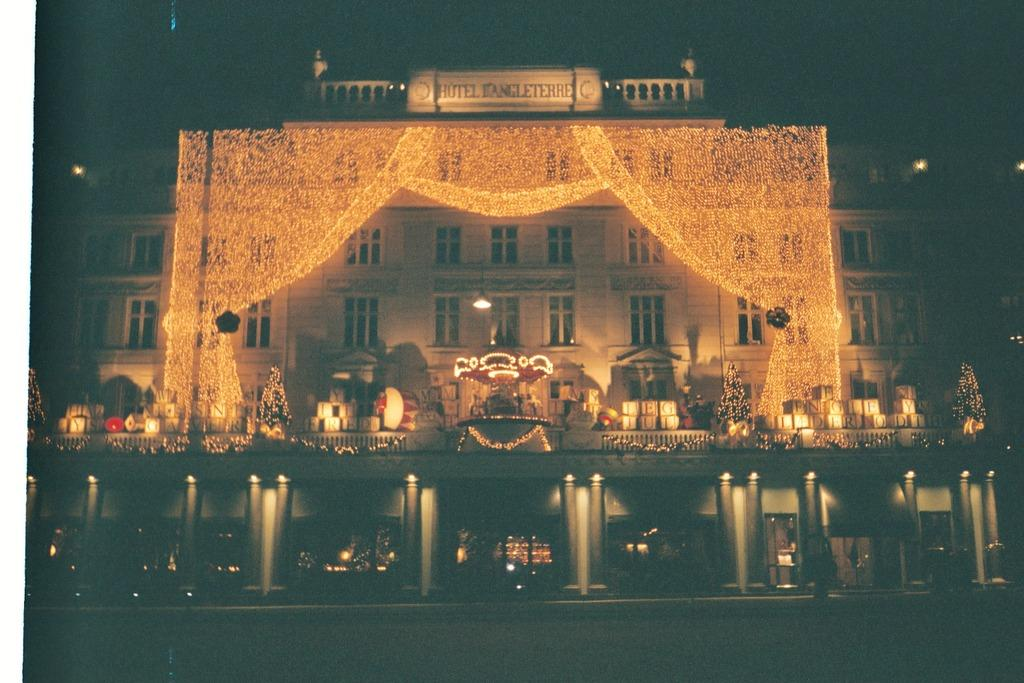What is the main subject of the image? The main subject of the image is a building. How is the building decorated? The building is decorated with lights. What can be seen above the building? There is something written above the building. How many kittens are playing with a berry on the roof of the building in the image? There are no kittens or berries present on the roof of the building in the image. What type of snails can be seen crawling on the walls of the building? There are no snails visible on the walls of the building in the image. 